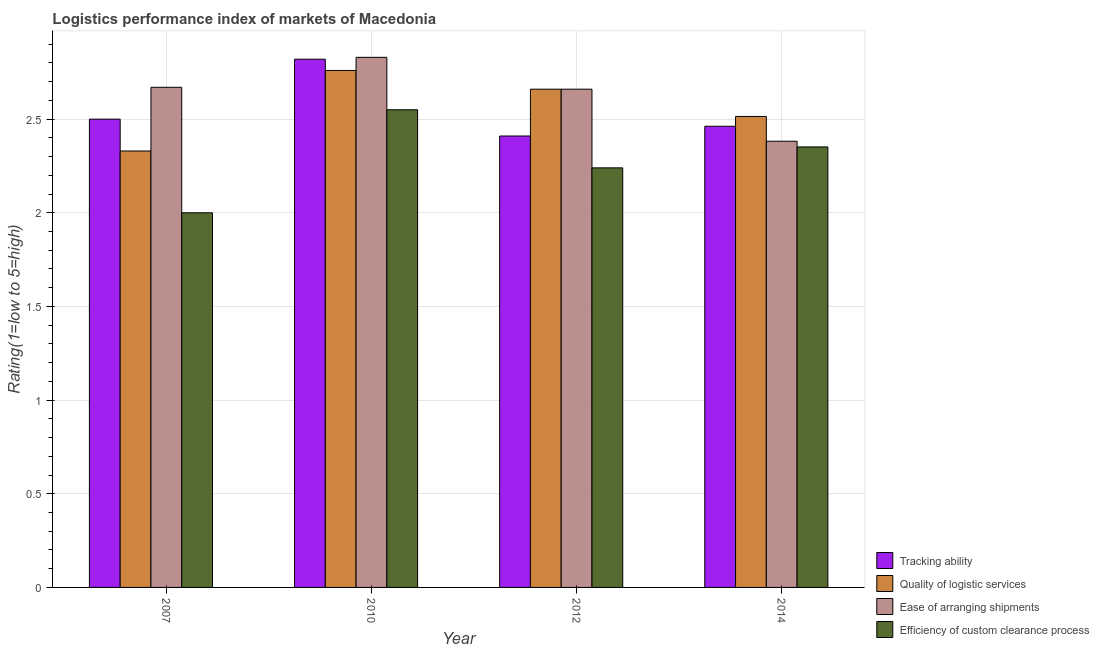Are the number of bars per tick equal to the number of legend labels?
Ensure brevity in your answer.  Yes. In how many cases, is the number of bars for a given year not equal to the number of legend labels?
Make the answer very short. 0. Across all years, what is the maximum lpi rating of tracking ability?
Make the answer very short. 2.82. Across all years, what is the minimum lpi rating of tracking ability?
Your response must be concise. 2.41. In which year was the lpi rating of ease of arranging shipments maximum?
Provide a succinct answer. 2010. In which year was the lpi rating of quality of logistic services minimum?
Keep it short and to the point. 2007. What is the total lpi rating of efficiency of custom clearance process in the graph?
Your answer should be compact. 9.14. What is the difference between the lpi rating of ease of arranging shipments in 2012 and that in 2014?
Provide a succinct answer. 0.28. What is the difference between the lpi rating of ease of arranging shipments in 2014 and the lpi rating of tracking ability in 2012?
Your response must be concise. -0.28. What is the average lpi rating of efficiency of custom clearance process per year?
Your response must be concise. 2.29. In the year 2007, what is the difference between the lpi rating of quality of logistic services and lpi rating of tracking ability?
Give a very brief answer. 0. What is the ratio of the lpi rating of ease of arranging shipments in 2007 to that in 2012?
Provide a succinct answer. 1. What is the difference between the highest and the second highest lpi rating of quality of logistic services?
Your answer should be compact. 0.1. What is the difference between the highest and the lowest lpi rating of quality of logistic services?
Keep it short and to the point. 0.43. In how many years, is the lpi rating of ease of arranging shipments greater than the average lpi rating of ease of arranging shipments taken over all years?
Keep it short and to the point. 3. Is the sum of the lpi rating of quality of logistic services in 2007 and 2012 greater than the maximum lpi rating of efficiency of custom clearance process across all years?
Give a very brief answer. Yes. What does the 2nd bar from the left in 2014 represents?
Keep it short and to the point. Quality of logistic services. What does the 1st bar from the right in 2012 represents?
Make the answer very short. Efficiency of custom clearance process. Is it the case that in every year, the sum of the lpi rating of tracking ability and lpi rating of quality of logistic services is greater than the lpi rating of ease of arranging shipments?
Ensure brevity in your answer.  Yes. How many bars are there?
Provide a short and direct response. 16. Are all the bars in the graph horizontal?
Make the answer very short. No. How many years are there in the graph?
Provide a short and direct response. 4. Does the graph contain grids?
Make the answer very short. Yes. Where does the legend appear in the graph?
Offer a very short reply. Bottom right. How are the legend labels stacked?
Give a very brief answer. Vertical. What is the title of the graph?
Give a very brief answer. Logistics performance index of markets of Macedonia. What is the label or title of the Y-axis?
Ensure brevity in your answer.  Rating(1=low to 5=high). What is the Rating(1=low to 5=high) in Quality of logistic services in 2007?
Your answer should be compact. 2.33. What is the Rating(1=low to 5=high) in Ease of arranging shipments in 2007?
Provide a succinct answer. 2.67. What is the Rating(1=low to 5=high) of Tracking ability in 2010?
Keep it short and to the point. 2.82. What is the Rating(1=low to 5=high) of Quality of logistic services in 2010?
Keep it short and to the point. 2.76. What is the Rating(1=low to 5=high) in Ease of arranging shipments in 2010?
Your answer should be very brief. 2.83. What is the Rating(1=low to 5=high) in Efficiency of custom clearance process in 2010?
Offer a terse response. 2.55. What is the Rating(1=low to 5=high) in Tracking ability in 2012?
Your response must be concise. 2.41. What is the Rating(1=low to 5=high) in Quality of logistic services in 2012?
Your response must be concise. 2.66. What is the Rating(1=low to 5=high) in Ease of arranging shipments in 2012?
Make the answer very short. 2.66. What is the Rating(1=low to 5=high) of Efficiency of custom clearance process in 2012?
Your answer should be very brief. 2.24. What is the Rating(1=low to 5=high) of Tracking ability in 2014?
Make the answer very short. 2.46. What is the Rating(1=low to 5=high) in Quality of logistic services in 2014?
Make the answer very short. 2.51. What is the Rating(1=low to 5=high) of Ease of arranging shipments in 2014?
Make the answer very short. 2.38. What is the Rating(1=low to 5=high) in Efficiency of custom clearance process in 2014?
Ensure brevity in your answer.  2.35. Across all years, what is the maximum Rating(1=low to 5=high) in Tracking ability?
Keep it short and to the point. 2.82. Across all years, what is the maximum Rating(1=low to 5=high) of Quality of logistic services?
Ensure brevity in your answer.  2.76. Across all years, what is the maximum Rating(1=low to 5=high) of Ease of arranging shipments?
Offer a terse response. 2.83. Across all years, what is the maximum Rating(1=low to 5=high) of Efficiency of custom clearance process?
Give a very brief answer. 2.55. Across all years, what is the minimum Rating(1=low to 5=high) of Tracking ability?
Give a very brief answer. 2.41. Across all years, what is the minimum Rating(1=low to 5=high) in Quality of logistic services?
Offer a very short reply. 2.33. Across all years, what is the minimum Rating(1=low to 5=high) of Ease of arranging shipments?
Your answer should be compact. 2.38. What is the total Rating(1=low to 5=high) of Tracking ability in the graph?
Your response must be concise. 10.19. What is the total Rating(1=low to 5=high) of Quality of logistic services in the graph?
Ensure brevity in your answer.  10.26. What is the total Rating(1=low to 5=high) in Ease of arranging shipments in the graph?
Ensure brevity in your answer.  10.54. What is the total Rating(1=low to 5=high) of Efficiency of custom clearance process in the graph?
Give a very brief answer. 9.14. What is the difference between the Rating(1=low to 5=high) in Tracking ability in 2007 and that in 2010?
Your response must be concise. -0.32. What is the difference between the Rating(1=low to 5=high) of Quality of logistic services in 2007 and that in 2010?
Give a very brief answer. -0.43. What is the difference between the Rating(1=low to 5=high) in Ease of arranging shipments in 2007 and that in 2010?
Your answer should be very brief. -0.16. What is the difference between the Rating(1=low to 5=high) of Efficiency of custom clearance process in 2007 and that in 2010?
Offer a terse response. -0.55. What is the difference between the Rating(1=low to 5=high) in Tracking ability in 2007 and that in 2012?
Your answer should be compact. 0.09. What is the difference between the Rating(1=low to 5=high) of Quality of logistic services in 2007 and that in 2012?
Your answer should be compact. -0.33. What is the difference between the Rating(1=low to 5=high) of Efficiency of custom clearance process in 2007 and that in 2012?
Provide a short and direct response. -0.24. What is the difference between the Rating(1=low to 5=high) of Tracking ability in 2007 and that in 2014?
Ensure brevity in your answer.  0.04. What is the difference between the Rating(1=low to 5=high) of Quality of logistic services in 2007 and that in 2014?
Make the answer very short. -0.18. What is the difference between the Rating(1=low to 5=high) in Ease of arranging shipments in 2007 and that in 2014?
Give a very brief answer. 0.29. What is the difference between the Rating(1=low to 5=high) in Efficiency of custom clearance process in 2007 and that in 2014?
Your answer should be compact. -0.35. What is the difference between the Rating(1=low to 5=high) of Tracking ability in 2010 and that in 2012?
Provide a short and direct response. 0.41. What is the difference between the Rating(1=low to 5=high) of Ease of arranging shipments in 2010 and that in 2012?
Offer a terse response. 0.17. What is the difference between the Rating(1=low to 5=high) of Efficiency of custom clearance process in 2010 and that in 2012?
Keep it short and to the point. 0.31. What is the difference between the Rating(1=low to 5=high) in Tracking ability in 2010 and that in 2014?
Offer a very short reply. 0.36. What is the difference between the Rating(1=low to 5=high) in Quality of logistic services in 2010 and that in 2014?
Provide a short and direct response. 0.25. What is the difference between the Rating(1=low to 5=high) of Ease of arranging shipments in 2010 and that in 2014?
Your response must be concise. 0.45. What is the difference between the Rating(1=low to 5=high) of Efficiency of custom clearance process in 2010 and that in 2014?
Offer a terse response. 0.2. What is the difference between the Rating(1=low to 5=high) of Tracking ability in 2012 and that in 2014?
Keep it short and to the point. -0.05. What is the difference between the Rating(1=low to 5=high) of Quality of logistic services in 2012 and that in 2014?
Offer a terse response. 0.15. What is the difference between the Rating(1=low to 5=high) in Ease of arranging shipments in 2012 and that in 2014?
Provide a short and direct response. 0.28. What is the difference between the Rating(1=low to 5=high) of Efficiency of custom clearance process in 2012 and that in 2014?
Provide a succinct answer. -0.11. What is the difference between the Rating(1=low to 5=high) in Tracking ability in 2007 and the Rating(1=low to 5=high) in Quality of logistic services in 2010?
Give a very brief answer. -0.26. What is the difference between the Rating(1=low to 5=high) of Tracking ability in 2007 and the Rating(1=low to 5=high) of Ease of arranging shipments in 2010?
Make the answer very short. -0.33. What is the difference between the Rating(1=low to 5=high) in Tracking ability in 2007 and the Rating(1=low to 5=high) in Efficiency of custom clearance process in 2010?
Your response must be concise. -0.05. What is the difference between the Rating(1=low to 5=high) of Quality of logistic services in 2007 and the Rating(1=low to 5=high) of Ease of arranging shipments in 2010?
Offer a very short reply. -0.5. What is the difference between the Rating(1=low to 5=high) in Quality of logistic services in 2007 and the Rating(1=low to 5=high) in Efficiency of custom clearance process in 2010?
Your answer should be compact. -0.22. What is the difference between the Rating(1=low to 5=high) in Ease of arranging shipments in 2007 and the Rating(1=low to 5=high) in Efficiency of custom clearance process in 2010?
Provide a succinct answer. 0.12. What is the difference between the Rating(1=low to 5=high) of Tracking ability in 2007 and the Rating(1=low to 5=high) of Quality of logistic services in 2012?
Provide a succinct answer. -0.16. What is the difference between the Rating(1=low to 5=high) of Tracking ability in 2007 and the Rating(1=low to 5=high) of Ease of arranging shipments in 2012?
Your answer should be compact. -0.16. What is the difference between the Rating(1=low to 5=high) of Tracking ability in 2007 and the Rating(1=low to 5=high) of Efficiency of custom clearance process in 2012?
Your answer should be very brief. 0.26. What is the difference between the Rating(1=low to 5=high) of Quality of logistic services in 2007 and the Rating(1=low to 5=high) of Ease of arranging shipments in 2012?
Your response must be concise. -0.33. What is the difference between the Rating(1=low to 5=high) of Quality of logistic services in 2007 and the Rating(1=low to 5=high) of Efficiency of custom clearance process in 2012?
Your answer should be very brief. 0.09. What is the difference between the Rating(1=low to 5=high) of Ease of arranging shipments in 2007 and the Rating(1=low to 5=high) of Efficiency of custom clearance process in 2012?
Provide a succinct answer. 0.43. What is the difference between the Rating(1=low to 5=high) of Tracking ability in 2007 and the Rating(1=low to 5=high) of Quality of logistic services in 2014?
Give a very brief answer. -0.01. What is the difference between the Rating(1=low to 5=high) in Tracking ability in 2007 and the Rating(1=low to 5=high) in Ease of arranging shipments in 2014?
Give a very brief answer. 0.12. What is the difference between the Rating(1=low to 5=high) in Tracking ability in 2007 and the Rating(1=low to 5=high) in Efficiency of custom clearance process in 2014?
Your response must be concise. 0.15. What is the difference between the Rating(1=low to 5=high) of Quality of logistic services in 2007 and the Rating(1=low to 5=high) of Ease of arranging shipments in 2014?
Your answer should be compact. -0.05. What is the difference between the Rating(1=low to 5=high) of Quality of logistic services in 2007 and the Rating(1=low to 5=high) of Efficiency of custom clearance process in 2014?
Your answer should be very brief. -0.02. What is the difference between the Rating(1=low to 5=high) in Ease of arranging shipments in 2007 and the Rating(1=low to 5=high) in Efficiency of custom clearance process in 2014?
Give a very brief answer. 0.32. What is the difference between the Rating(1=low to 5=high) of Tracking ability in 2010 and the Rating(1=low to 5=high) of Quality of logistic services in 2012?
Your answer should be compact. 0.16. What is the difference between the Rating(1=low to 5=high) in Tracking ability in 2010 and the Rating(1=low to 5=high) in Ease of arranging shipments in 2012?
Ensure brevity in your answer.  0.16. What is the difference between the Rating(1=low to 5=high) of Tracking ability in 2010 and the Rating(1=low to 5=high) of Efficiency of custom clearance process in 2012?
Give a very brief answer. 0.58. What is the difference between the Rating(1=low to 5=high) in Quality of logistic services in 2010 and the Rating(1=low to 5=high) in Efficiency of custom clearance process in 2012?
Make the answer very short. 0.52. What is the difference between the Rating(1=low to 5=high) in Ease of arranging shipments in 2010 and the Rating(1=low to 5=high) in Efficiency of custom clearance process in 2012?
Keep it short and to the point. 0.59. What is the difference between the Rating(1=low to 5=high) in Tracking ability in 2010 and the Rating(1=low to 5=high) in Quality of logistic services in 2014?
Provide a succinct answer. 0.31. What is the difference between the Rating(1=low to 5=high) in Tracking ability in 2010 and the Rating(1=low to 5=high) in Ease of arranging shipments in 2014?
Provide a short and direct response. 0.44. What is the difference between the Rating(1=low to 5=high) of Tracking ability in 2010 and the Rating(1=low to 5=high) of Efficiency of custom clearance process in 2014?
Your answer should be compact. 0.47. What is the difference between the Rating(1=low to 5=high) of Quality of logistic services in 2010 and the Rating(1=low to 5=high) of Ease of arranging shipments in 2014?
Ensure brevity in your answer.  0.38. What is the difference between the Rating(1=low to 5=high) of Quality of logistic services in 2010 and the Rating(1=low to 5=high) of Efficiency of custom clearance process in 2014?
Offer a very short reply. 0.41. What is the difference between the Rating(1=low to 5=high) in Ease of arranging shipments in 2010 and the Rating(1=low to 5=high) in Efficiency of custom clearance process in 2014?
Your answer should be compact. 0.48. What is the difference between the Rating(1=low to 5=high) in Tracking ability in 2012 and the Rating(1=low to 5=high) in Quality of logistic services in 2014?
Keep it short and to the point. -0.1. What is the difference between the Rating(1=low to 5=high) of Tracking ability in 2012 and the Rating(1=low to 5=high) of Ease of arranging shipments in 2014?
Your response must be concise. 0.03. What is the difference between the Rating(1=low to 5=high) of Tracking ability in 2012 and the Rating(1=low to 5=high) of Efficiency of custom clearance process in 2014?
Keep it short and to the point. 0.06. What is the difference between the Rating(1=low to 5=high) of Quality of logistic services in 2012 and the Rating(1=low to 5=high) of Ease of arranging shipments in 2014?
Your answer should be very brief. 0.28. What is the difference between the Rating(1=low to 5=high) of Quality of logistic services in 2012 and the Rating(1=low to 5=high) of Efficiency of custom clearance process in 2014?
Offer a terse response. 0.31. What is the difference between the Rating(1=low to 5=high) of Ease of arranging shipments in 2012 and the Rating(1=low to 5=high) of Efficiency of custom clearance process in 2014?
Provide a short and direct response. 0.31. What is the average Rating(1=low to 5=high) of Tracking ability per year?
Your answer should be compact. 2.55. What is the average Rating(1=low to 5=high) of Quality of logistic services per year?
Offer a terse response. 2.57. What is the average Rating(1=low to 5=high) in Ease of arranging shipments per year?
Give a very brief answer. 2.64. What is the average Rating(1=low to 5=high) in Efficiency of custom clearance process per year?
Provide a succinct answer. 2.29. In the year 2007, what is the difference between the Rating(1=low to 5=high) of Tracking ability and Rating(1=low to 5=high) of Quality of logistic services?
Your answer should be very brief. 0.17. In the year 2007, what is the difference between the Rating(1=low to 5=high) of Tracking ability and Rating(1=low to 5=high) of Ease of arranging shipments?
Your answer should be very brief. -0.17. In the year 2007, what is the difference between the Rating(1=low to 5=high) of Tracking ability and Rating(1=low to 5=high) of Efficiency of custom clearance process?
Keep it short and to the point. 0.5. In the year 2007, what is the difference between the Rating(1=low to 5=high) in Quality of logistic services and Rating(1=low to 5=high) in Ease of arranging shipments?
Offer a terse response. -0.34. In the year 2007, what is the difference between the Rating(1=low to 5=high) of Quality of logistic services and Rating(1=low to 5=high) of Efficiency of custom clearance process?
Provide a succinct answer. 0.33. In the year 2007, what is the difference between the Rating(1=low to 5=high) of Ease of arranging shipments and Rating(1=low to 5=high) of Efficiency of custom clearance process?
Ensure brevity in your answer.  0.67. In the year 2010, what is the difference between the Rating(1=low to 5=high) in Tracking ability and Rating(1=low to 5=high) in Ease of arranging shipments?
Offer a very short reply. -0.01. In the year 2010, what is the difference between the Rating(1=low to 5=high) in Tracking ability and Rating(1=low to 5=high) in Efficiency of custom clearance process?
Your answer should be very brief. 0.27. In the year 2010, what is the difference between the Rating(1=low to 5=high) of Quality of logistic services and Rating(1=low to 5=high) of Ease of arranging shipments?
Provide a succinct answer. -0.07. In the year 2010, what is the difference between the Rating(1=low to 5=high) in Quality of logistic services and Rating(1=low to 5=high) in Efficiency of custom clearance process?
Keep it short and to the point. 0.21. In the year 2010, what is the difference between the Rating(1=low to 5=high) in Ease of arranging shipments and Rating(1=low to 5=high) in Efficiency of custom clearance process?
Give a very brief answer. 0.28. In the year 2012, what is the difference between the Rating(1=low to 5=high) in Tracking ability and Rating(1=low to 5=high) in Quality of logistic services?
Make the answer very short. -0.25. In the year 2012, what is the difference between the Rating(1=low to 5=high) of Tracking ability and Rating(1=low to 5=high) of Efficiency of custom clearance process?
Offer a very short reply. 0.17. In the year 2012, what is the difference between the Rating(1=low to 5=high) in Quality of logistic services and Rating(1=low to 5=high) in Efficiency of custom clearance process?
Your answer should be compact. 0.42. In the year 2012, what is the difference between the Rating(1=low to 5=high) of Ease of arranging shipments and Rating(1=low to 5=high) of Efficiency of custom clearance process?
Offer a terse response. 0.42. In the year 2014, what is the difference between the Rating(1=low to 5=high) in Tracking ability and Rating(1=low to 5=high) in Quality of logistic services?
Offer a terse response. -0.05. In the year 2014, what is the difference between the Rating(1=low to 5=high) in Tracking ability and Rating(1=low to 5=high) in Ease of arranging shipments?
Provide a short and direct response. 0.08. In the year 2014, what is the difference between the Rating(1=low to 5=high) of Tracking ability and Rating(1=low to 5=high) of Efficiency of custom clearance process?
Make the answer very short. 0.11. In the year 2014, what is the difference between the Rating(1=low to 5=high) of Quality of logistic services and Rating(1=low to 5=high) of Ease of arranging shipments?
Your answer should be very brief. 0.13. In the year 2014, what is the difference between the Rating(1=low to 5=high) in Quality of logistic services and Rating(1=low to 5=high) in Efficiency of custom clearance process?
Your answer should be very brief. 0.16. In the year 2014, what is the difference between the Rating(1=low to 5=high) in Ease of arranging shipments and Rating(1=low to 5=high) in Efficiency of custom clearance process?
Your response must be concise. 0.03. What is the ratio of the Rating(1=low to 5=high) in Tracking ability in 2007 to that in 2010?
Your response must be concise. 0.89. What is the ratio of the Rating(1=low to 5=high) in Quality of logistic services in 2007 to that in 2010?
Give a very brief answer. 0.84. What is the ratio of the Rating(1=low to 5=high) in Ease of arranging shipments in 2007 to that in 2010?
Ensure brevity in your answer.  0.94. What is the ratio of the Rating(1=low to 5=high) of Efficiency of custom clearance process in 2007 to that in 2010?
Your response must be concise. 0.78. What is the ratio of the Rating(1=low to 5=high) in Tracking ability in 2007 to that in 2012?
Your answer should be very brief. 1.04. What is the ratio of the Rating(1=low to 5=high) of Quality of logistic services in 2007 to that in 2012?
Ensure brevity in your answer.  0.88. What is the ratio of the Rating(1=low to 5=high) of Efficiency of custom clearance process in 2007 to that in 2012?
Your response must be concise. 0.89. What is the ratio of the Rating(1=low to 5=high) in Tracking ability in 2007 to that in 2014?
Ensure brevity in your answer.  1.02. What is the ratio of the Rating(1=low to 5=high) of Quality of logistic services in 2007 to that in 2014?
Ensure brevity in your answer.  0.93. What is the ratio of the Rating(1=low to 5=high) in Ease of arranging shipments in 2007 to that in 2014?
Your answer should be compact. 1.12. What is the ratio of the Rating(1=low to 5=high) in Efficiency of custom clearance process in 2007 to that in 2014?
Offer a very short reply. 0.85. What is the ratio of the Rating(1=low to 5=high) in Tracking ability in 2010 to that in 2012?
Offer a very short reply. 1.17. What is the ratio of the Rating(1=low to 5=high) in Quality of logistic services in 2010 to that in 2012?
Ensure brevity in your answer.  1.04. What is the ratio of the Rating(1=low to 5=high) of Ease of arranging shipments in 2010 to that in 2012?
Ensure brevity in your answer.  1.06. What is the ratio of the Rating(1=low to 5=high) in Efficiency of custom clearance process in 2010 to that in 2012?
Your answer should be very brief. 1.14. What is the ratio of the Rating(1=low to 5=high) of Tracking ability in 2010 to that in 2014?
Ensure brevity in your answer.  1.15. What is the ratio of the Rating(1=low to 5=high) of Quality of logistic services in 2010 to that in 2014?
Keep it short and to the point. 1.1. What is the ratio of the Rating(1=low to 5=high) in Ease of arranging shipments in 2010 to that in 2014?
Make the answer very short. 1.19. What is the ratio of the Rating(1=low to 5=high) of Efficiency of custom clearance process in 2010 to that in 2014?
Your answer should be very brief. 1.08. What is the ratio of the Rating(1=low to 5=high) in Tracking ability in 2012 to that in 2014?
Provide a succinct answer. 0.98. What is the ratio of the Rating(1=low to 5=high) of Quality of logistic services in 2012 to that in 2014?
Your answer should be compact. 1.06. What is the ratio of the Rating(1=low to 5=high) in Ease of arranging shipments in 2012 to that in 2014?
Provide a short and direct response. 1.12. What is the ratio of the Rating(1=low to 5=high) of Efficiency of custom clearance process in 2012 to that in 2014?
Provide a succinct answer. 0.95. What is the difference between the highest and the second highest Rating(1=low to 5=high) in Tracking ability?
Your answer should be compact. 0.32. What is the difference between the highest and the second highest Rating(1=low to 5=high) of Ease of arranging shipments?
Ensure brevity in your answer.  0.16. What is the difference between the highest and the second highest Rating(1=low to 5=high) of Efficiency of custom clearance process?
Provide a succinct answer. 0.2. What is the difference between the highest and the lowest Rating(1=low to 5=high) of Tracking ability?
Provide a succinct answer. 0.41. What is the difference between the highest and the lowest Rating(1=low to 5=high) in Quality of logistic services?
Your response must be concise. 0.43. What is the difference between the highest and the lowest Rating(1=low to 5=high) in Ease of arranging shipments?
Your answer should be compact. 0.45. What is the difference between the highest and the lowest Rating(1=low to 5=high) of Efficiency of custom clearance process?
Make the answer very short. 0.55. 